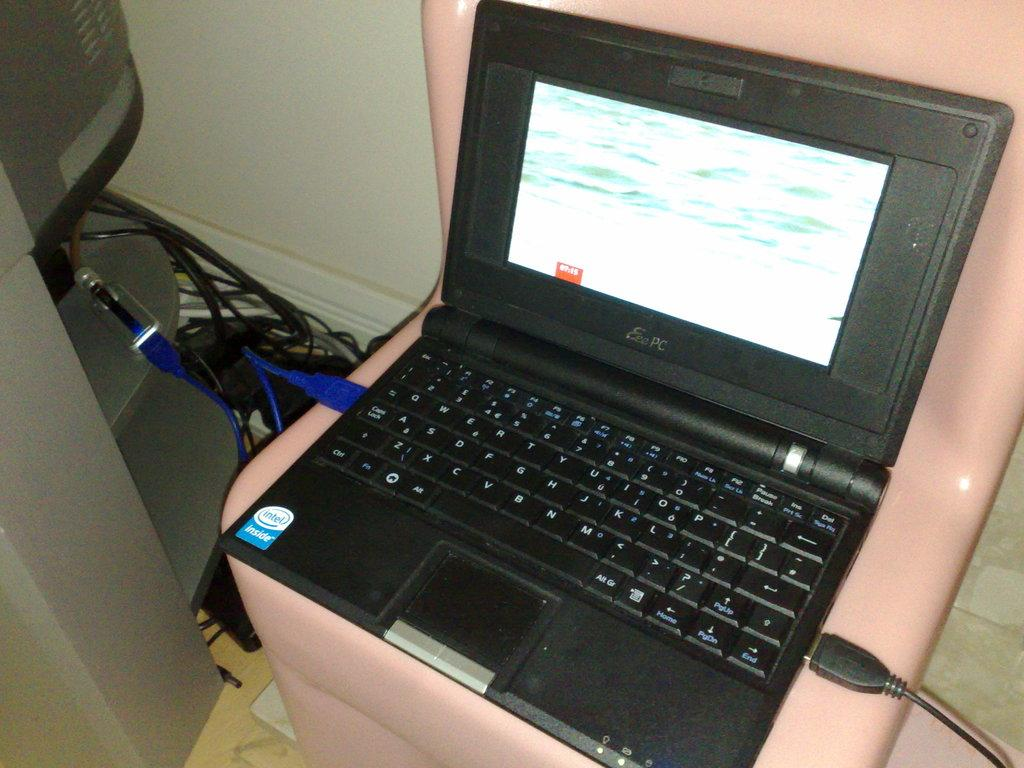What electronic device is visible in the image? There is a laptop in the image. What else can be seen on the left side of the image? There are wires on the left side of the image. What type of silk is being used to improve the health of the farmer in the image? There is no silk, health, or farmer present in the image. 